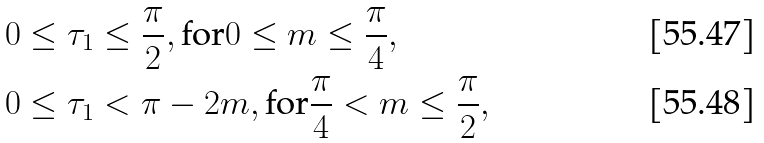Convert formula to latex. <formula><loc_0><loc_0><loc_500><loc_500>& 0 \leq \tau _ { 1 } \leq \frac { \pi } { 2 } , \text {for} 0 \leq m \leq \frac { \pi } { 4 } , \\ & 0 \leq \tau _ { 1 } < \pi - 2 m , \text {for} \frac { \pi } { 4 } < m \leq \frac { \pi } { 2 } ,</formula> 